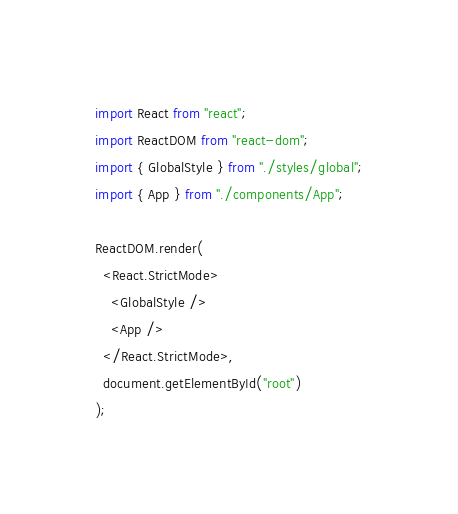<code> <loc_0><loc_0><loc_500><loc_500><_JavaScript_>import React from "react";
import ReactDOM from "react-dom";
import { GlobalStyle } from "./styles/global";
import { App } from "./components/App";

ReactDOM.render(
  <React.StrictMode>
    <GlobalStyle />
    <App />
  </React.StrictMode>,
  document.getElementById("root")
);
</code> 